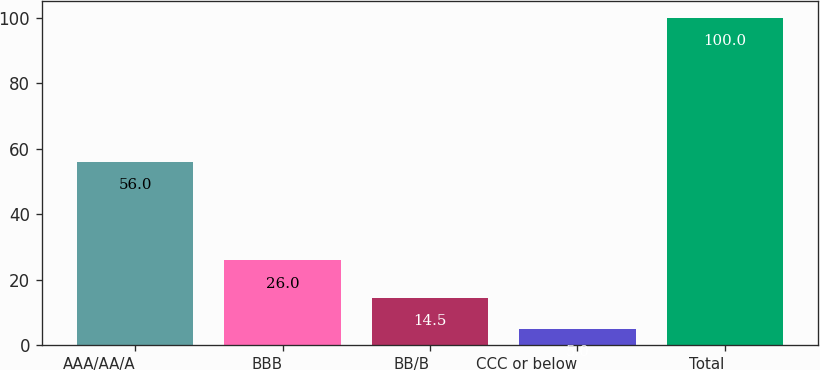<chart> <loc_0><loc_0><loc_500><loc_500><bar_chart><fcel>AAA/AA/A<fcel>BBB<fcel>BB/B<fcel>CCC or below<fcel>Total<nl><fcel>56<fcel>26<fcel>14.5<fcel>5<fcel>100<nl></chart> 